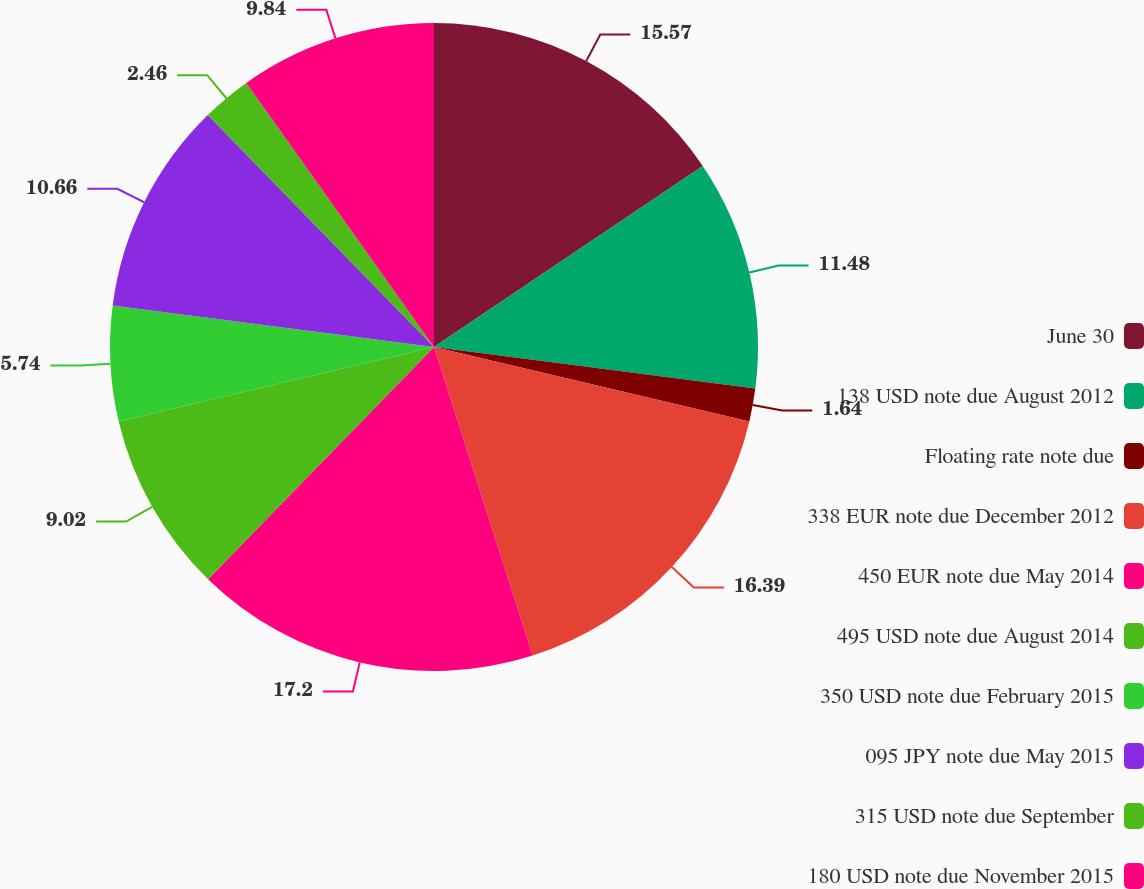Convert chart to OTSL. <chart><loc_0><loc_0><loc_500><loc_500><pie_chart><fcel>June 30<fcel>138 USD note due August 2012<fcel>Floating rate note due<fcel>338 EUR note due December 2012<fcel>450 EUR note due May 2014<fcel>495 USD note due August 2014<fcel>350 USD note due February 2015<fcel>095 JPY note due May 2015<fcel>315 USD note due September<fcel>180 USD note due November 2015<nl><fcel>15.57%<fcel>11.48%<fcel>1.64%<fcel>16.39%<fcel>17.21%<fcel>9.02%<fcel>5.74%<fcel>10.66%<fcel>2.46%<fcel>9.84%<nl></chart> 